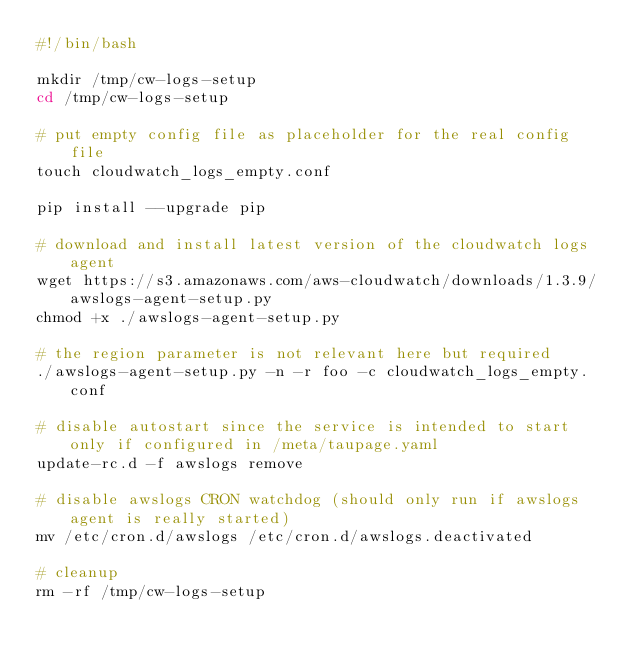<code> <loc_0><loc_0><loc_500><loc_500><_Bash_>#!/bin/bash

mkdir /tmp/cw-logs-setup
cd /tmp/cw-logs-setup

# put empty config file as placeholder for the real config file
touch cloudwatch_logs_empty.conf

pip install --upgrade pip

# download and install latest version of the cloudwatch logs agent
wget https://s3.amazonaws.com/aws-cloudwatch/downloads/1.3.9/awslogs-agent-setup.py
chmod +x ./awslogs-agent-setup.py

# the region parameter is not relevant here but required
./awslogs-agent-setup.py -n -r foo -c cloudwatch_logs_empty.conf

# disable autostart since the service is intended to start only if configured in /meta/taupage.yaml
update-rc.d -f awslogs remove

# disable awslogs CRON watchdog (should only run if awslogs agent is really started)
mv /etc/cron.d/awslogs /etc/cron.d/awslogs.deactivated

# cleanup
rm -rf /tmp/cw-logs-setup
</code> 